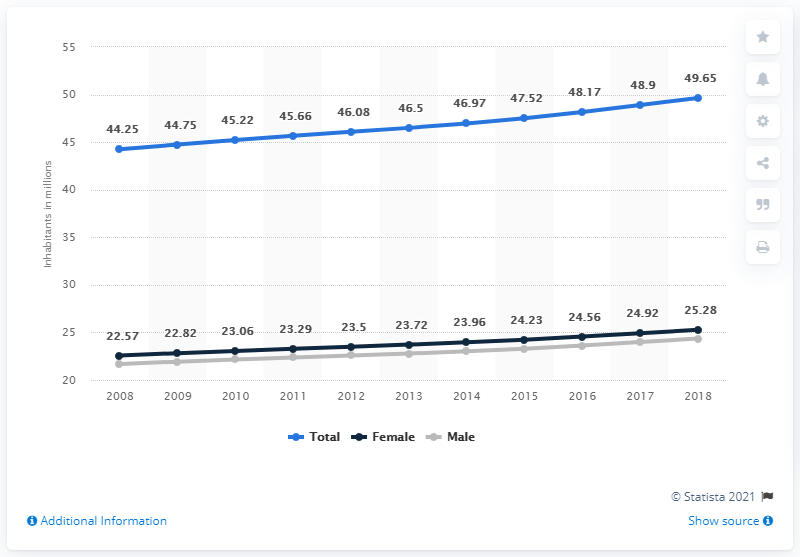Give some essential details in this illustration. In 2008, Colombia's population began to exhibit an upward trend. According to data from 2018, the population of Colombia was 49.65 million. 